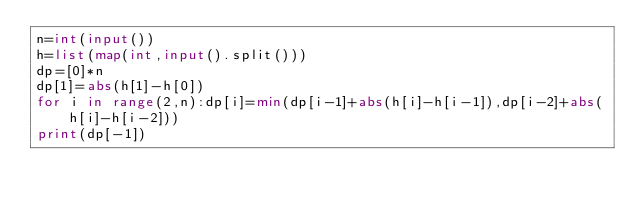<code> <loc_0><loc_0><loc_500><loc_500><_Python_>n=int(input())
h=list(map(int,input().split()))
dp=[0]*n
dp[1]=abs(h[1]-h[0])
for i in range(2,n):dp[i]=min(dp[i-1]+abs(h[i]-h[i-1]),dp[i-2]+abs(h[i]-h[i-2]))
print(dp[-1])</code> 